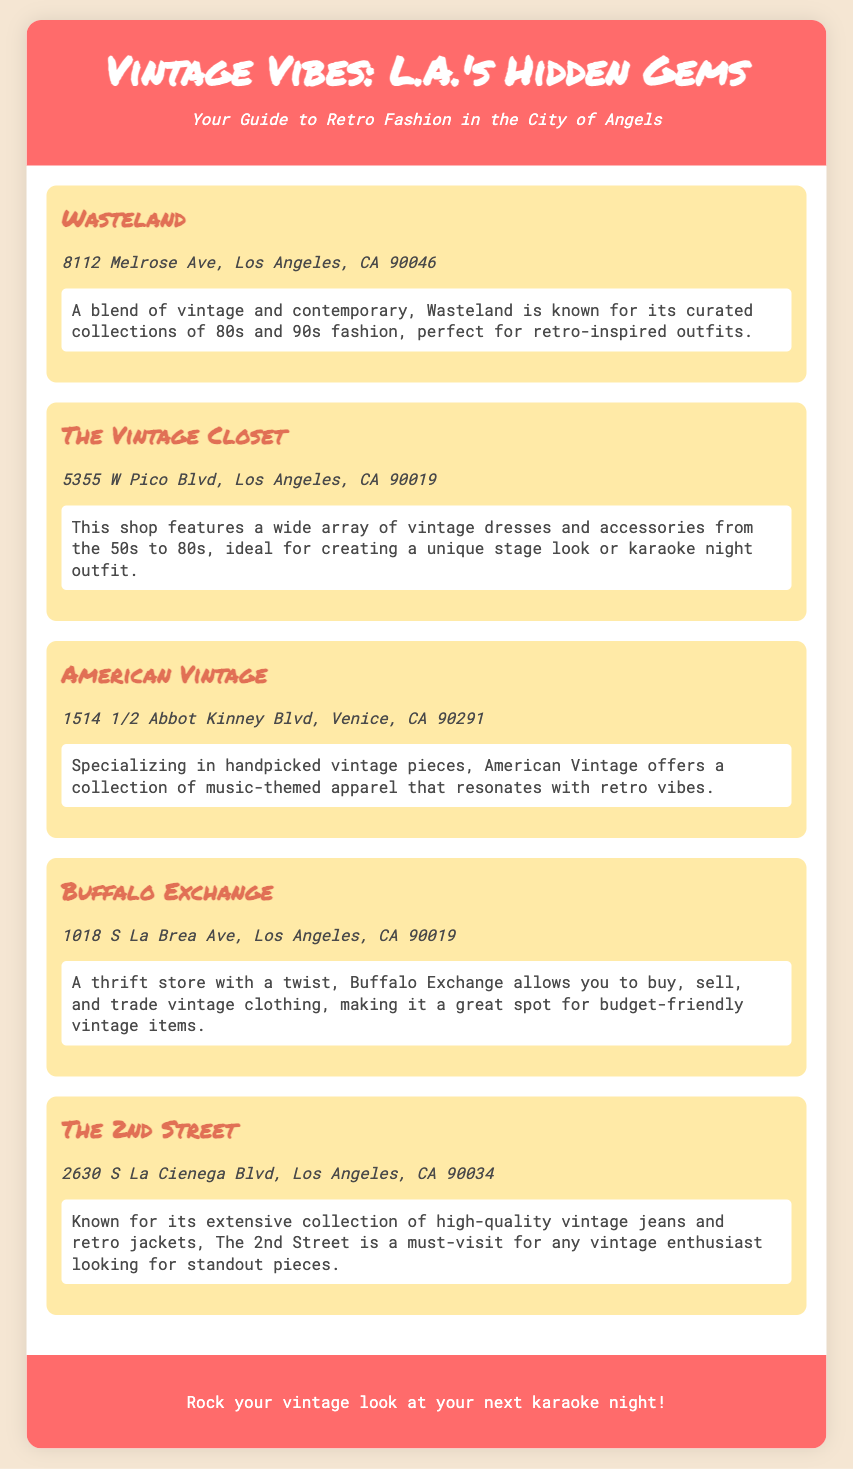What is the name of the shop at 8112 Melrose Ave? The shop at 8112 Melrose Ave is called Wasteland.
Answer: Wasteland What type of clothing is The Vintage Closet known for? The Vintage Closet features vintage dresses and accessories from the 50s to 80s.
Answer: Vintage dresses and accessories Where is American Vintage located? American Vintage is located at 1514 1/2 Abbot Kinney Blvd, Venice, CA 90291.
Answer: 1514 1/2 Abbot Kinney Blvd, Venice, CA 90291 What unique offering does Buffalo Exchange have? Buffalo Exchange allows you to buy, sell, and trade vintage clothing.
Answer: Buy, sell, and trade vintage clothing Which shop specializes in high-quality vintage jeans? The 2nd Street is known for its extensive collection of high-quality vintage jeans.
Answer: The 2nd Street What decade does Wasteland primarily focus on for fashion? Wasteland is known for its curated collections of 80s and 90s fashion.
Answer: 80s and 90s Which vintage shop features music-themed apparel? American Vintage specializes in music-themed apparel.
Answer: American Vintage How many shops are listed in the document? There are five shops listed in the document.
Answer: Five What is the background color of the shop item section? The shop item section has a background color of #ffeaa7.
Answer: #ffeaa7 